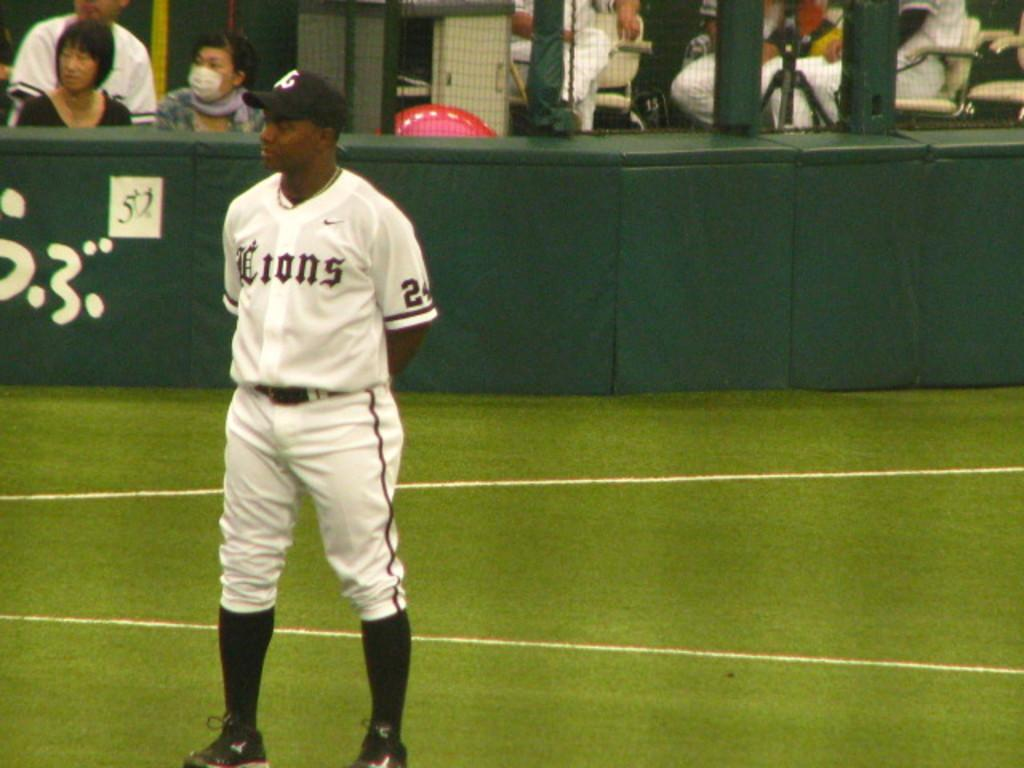<image>
Provide a brief description of the given image. A player for the Lions team stands on the field. 